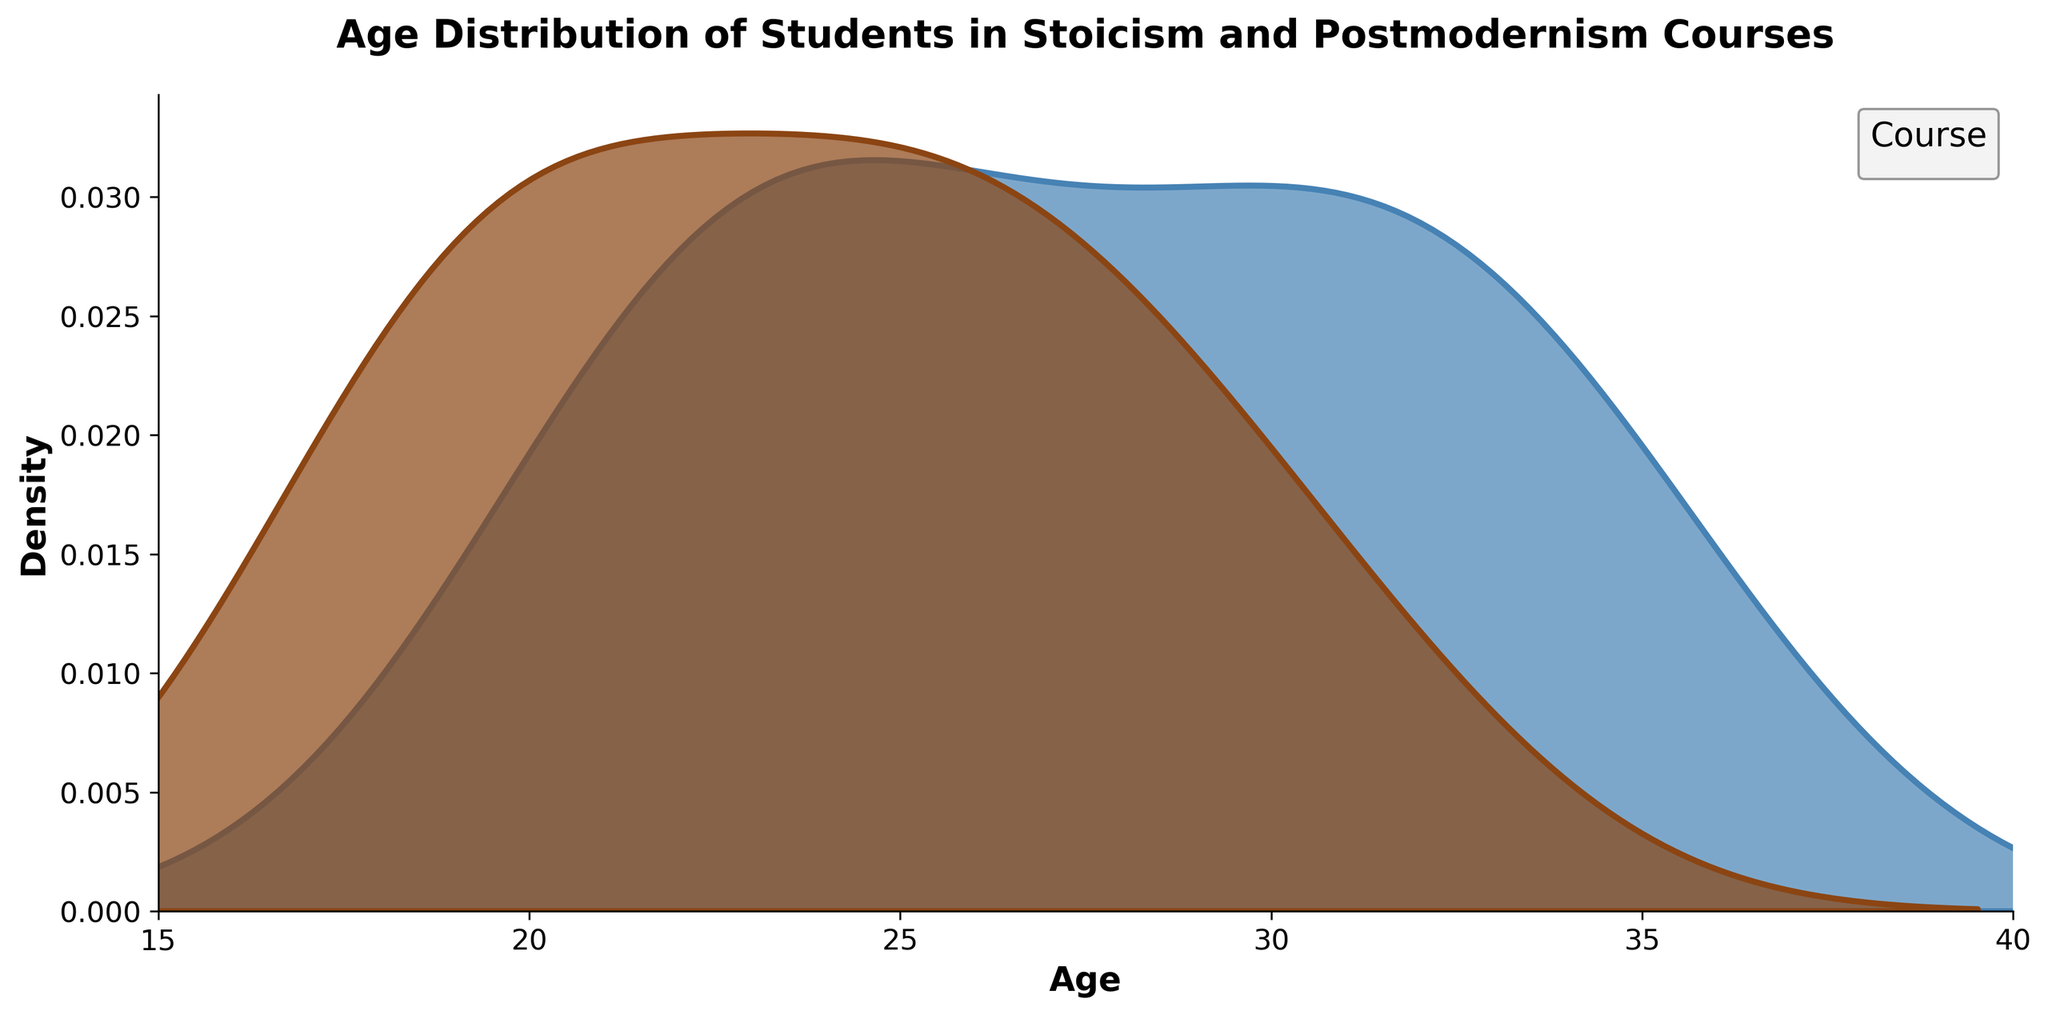What does the title of the plot indicate? The title of the plot is "Age Distribution of Students in Stoicism and Postmodernism Courses," which indicates that the plot shows how students' ages are distributed across two courses: Stoicism and Postmodernism.
Answer: Age Distribution of Students in Stoicism and Postmodernism Courses What are the x-axis labels and what do they represent? The x-axis label is "Age," and it represents the ages of the students enrolling in Stoicism and Postmodernism courses, indicating the range of these ages.
Answer: Age What is the color used to represent students enrolled in Stoicism courses? The color used to represent students enrolled in Stoicism courses is a shade of brown.
Answer: Brown In which age group is the density highest for Postmodernism students? The density is highest for Postmodernism students in the age group of approximately 30-35 years.
Answer: 30-35 years Which course has students with a more varied age range? By examining the spread of the density plot, it's evident that the age range of students enrolled in Postmodernism courses is more varied, stretching from around 18 to 35 years, compared to a narrower range for Stoicism.
Answer: Postmodernism At what age do Stoicism and Postmodernism students show a density overlap? Stoicism and Postmodernism students show a notable overlap in density around the age of 22-25 years.
Answer: 22-25 years What is the peak density value for students in the Stoicism course? The peak density for students in the Stoicism course appears to be around the age of 21-22 years.
Answer: 21-22 years Comparing both density plots, which course has a higher density at the age of 30? At the age of 30, the density for Postmodernism students is higher compared to Stoicism students, indicating more students of that age in Postmodernism courses.
Answer: Postmodernism How does the shape of the density curve for Postmodernism students suggest about their age distribution compared to Stoicism students? The shape of the density curve for Postmodernism students is wider and has multiple peaks, suggesting a more varied age distribution and the presence of different age clusters within the group. In contrast, the Stoicism students' density curve is narrower and more concentrated around younger ages.
Answer: Wider and varied for Postmodernism, narrower and concentrated for Stoicism At which age does the density of students in Stoicism courses begin to taper off significantly? The density of students in Stoicism courses begins to taper off significantly after the age of 28.
Answer: After 28 